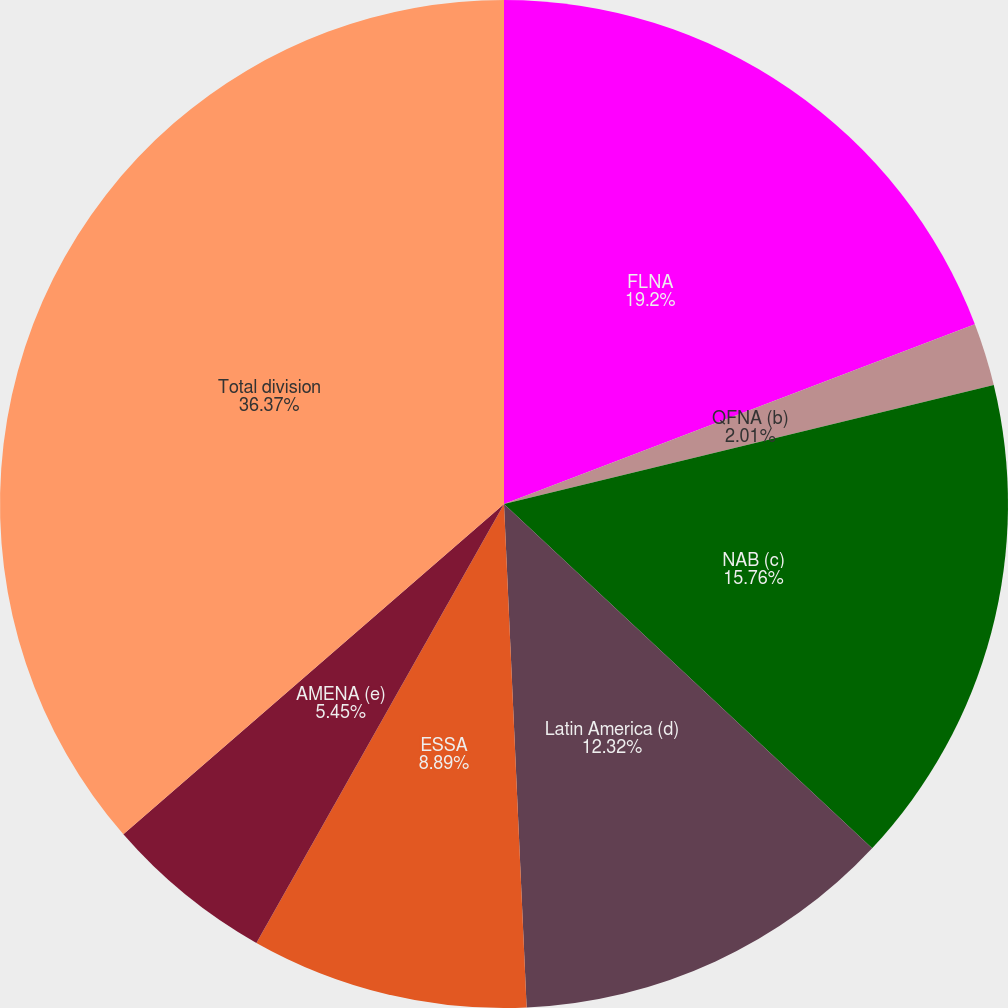Convert chart. <chart><loc_0><loc_0><loc_500><loc_500><pie_chart><fcel>FLNA<fcel>QFNA (b)<fcel>NAB (c)<fcel>Latin America (d)<fcel>ESSA<fcel>AMENA (e)<fcel>Total division<nl><fcel>19.2%<fcel>2.01%<fcel>15.76%<fcel>12.32%<fcel>8.89%<fcel>5.45%<fcel>36.38%<nl></chart> 